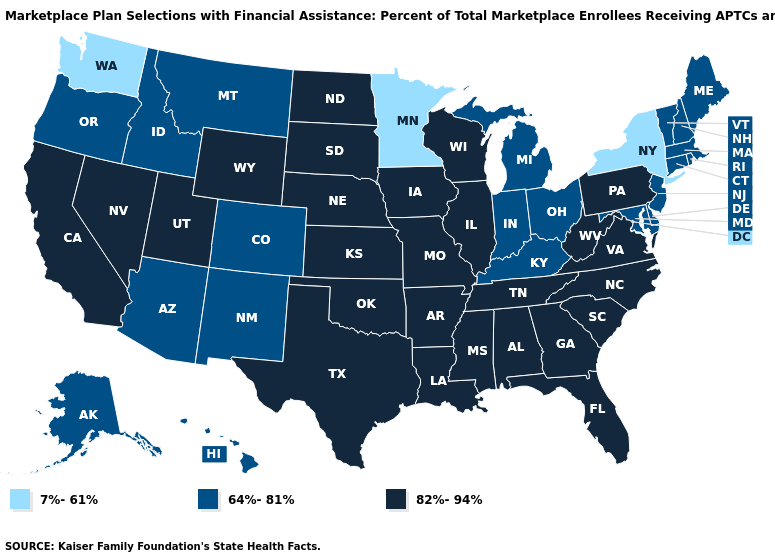Among the states that border Tennessee , which have the highest value?
Keep it brief. Alabama, Arkansas, Georgia, Mississippi, Missouri, North Carolina, Virginia. What is the lowest value in states that border Rhode Island?
Concise answer only. 64%-81%. What is the value of New York?
Keep it brief. 7%-61%. Which states have the highest value in the USA?
Write a very short answer. Alabama, Arkansas, California, Florida, Georgia, Illinois, Iowa, Kansas, Louisiana, Mississippi, Missouri, Nebraska, Nevada, North Carolina, North Dakota, Oklahoma, Pennsylvania, South Carolina, South Dakota, Tennessee, Texas, Utah, Virginia, West Virginia, Wisconsin, Wyoming. Name the states that have a value in the range 7%-61%?
Write a very short answer. Minnesota, New York, Washington. Does the map have missing data?
Keep it brief. No. Does Alaska have the lowest value in the West?
Concise answer only. No. Does Vermont have the lowest value in the Northeast?
Be succinct. No. Does New York have the lowest value in the USA?
Concise answer only. Yes. Does the first symbol in the legend represent the smallest category?
Answer briefly. Yes. Which states have the highest value in the USA?
Be succinct. Alabama, Arkansas, California, Florida, Georgia, Illinois, Iowa, Kansas, Louisiana, Mississippi, Missouri, Nebraska, Nevada, North Carolina, North Dakota, Oklahoma, Pennsylvania, South Carolina, South Dakota, Tennessee, Texas, Utah, Virginia, West Virginia, Wisconsin, Wyoming. What is the value of South Dakota?
Write a very short answer. 82%-94%. Does Kentucky have the lowest value in the USA?
Answer briefly. No. Does Washington have the lowest value in the USA?
Write a very short answer. Yes. Name the states that have a value in the range 7%-61%?
Concise answer only. Minnesota, New York, Washington. 